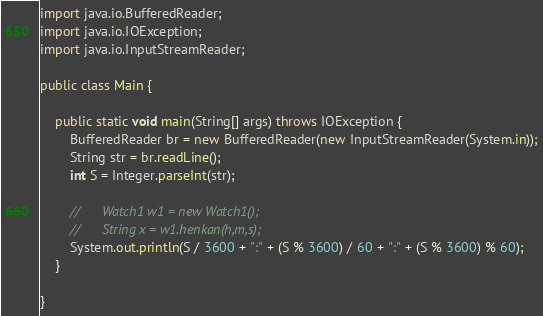<code> <loc_0><loc_0><loc_500><loc_500><_Java_>import java.io.BufferedReader;
import java.io.IOException;
import java.io.InputStreamReader;

public class Main {

	public static void main(String[] args) throws IOException {
		BufferedReader br = new BufferedReader(new InputStreamReader(System.in));
		String str = br.readLine();
		int S = Integer.parseInt(str);

		//		Watch1 w1 = new Watch1();
		//		String x = w1.henkan(h,m,s);
		System.out.println(S / 3600 + ":" + (S % 3600) / 60 + ":" + (S % 3600) % 60);
	}

}

</code> 